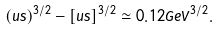<formula> <loc_0><loc_0><loc_500><loc_500>( u s ) ^ { 3 / 2 } - [ u s ] ^ { 3 / 2 } \simeq 0 . 1 2 G e V ^ { 3 / 2 } .</formula> 